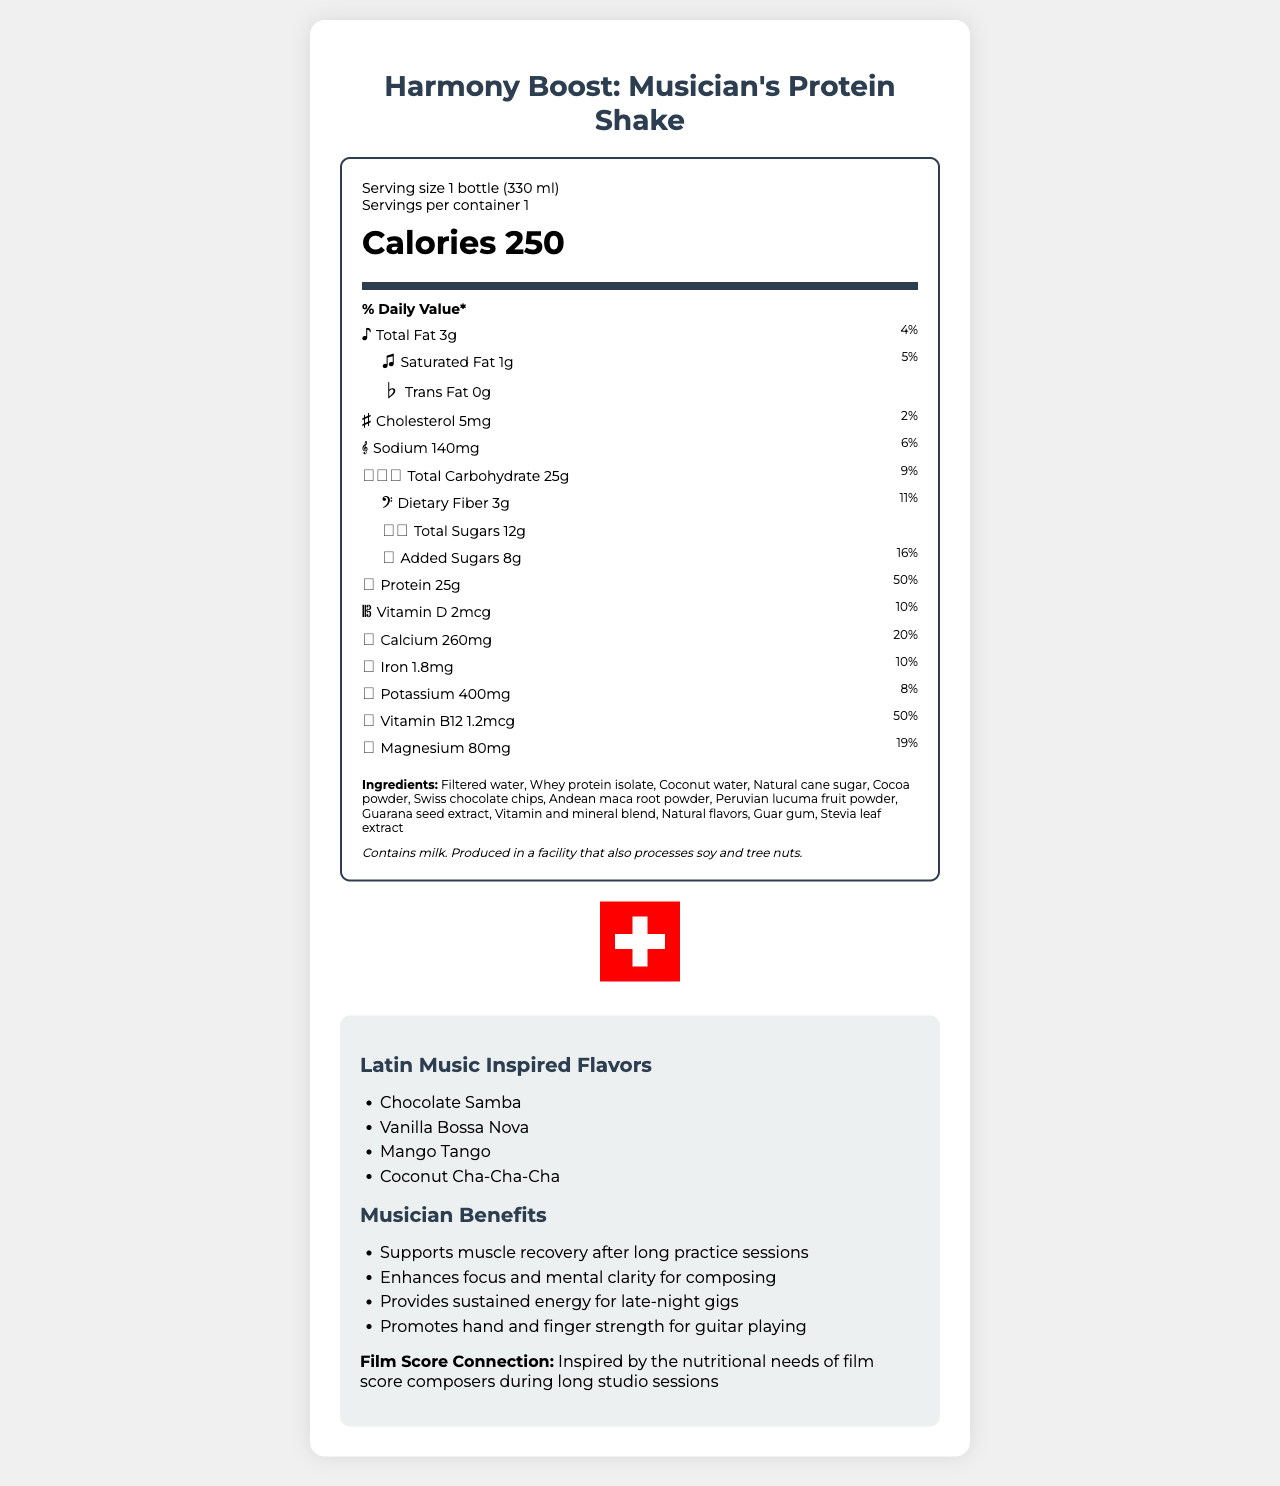what is the serving size? The serving size is mentioned in the serving information in the nutrition label section of the document.
Answer: 1 bottle (330 ml) how much protein does the shake provide? The protein amount is listed under the nutrients section with the note "Protein 25g (𝄚)".
Answer: 25g what is the daily value percentage for calcium? The daily value percentage for calcium is shown in the calcium row in the nutrient section, marked with the icon (𝄔).
Answer: 20% what flavors are available for the protein shake? The flavors are listed under the "Latin Music Inspired Flavors" section of the additional information.
Answer: Chocolate Samba, Vanilla Bossa Nova, Mango Tango, Coconut Cha-Cha-Cha what is the main source of protein in this shake? The main source of protein is listed first in the ingredients list, signifying its prominence in the shake composition.
Answer: Whey protein isolate how many grams of total sugars are in the shake? The total amount of sugars is listed in the nutrient section under "Total Sugars 12g (𝅗𝅥)".
Answer: 12g how much dietary fiber does the shake contain? A. 2g B. 3g C. 4g The document indicates that the shake contains 3g of dietary fiber (𝄢), with an 11% daily value.
Answer: B what percentage of the daily value of vitamin D does this shake provide? A. 5% B. 8% C. 10% D. 12% The shake provides 10% of the daily value for vitamin D, as shown in the nutrient information with the icon (𝄡).
Answer: C does the document specify if the protein shake is suitable for vegans? The document does not provide enough information regarding whether the product is suitable for vegans. It does list "Whey protein isolate" (a milk derivative), indicating it may not be vegan-friendly.
Answer: No is there any allergen information mentioned? The allergen information is included under the ingredients list, stating that the product contains milk and is produced in a facility that also processes soy and tree nuts.
Answer: Yes describe the main idea of the document. The document includes a detailed nutritional value table, a list of ingredients, allergen information, and highlights the product benefits for musicians. It also features unique Latin music-inspired flavors and a Swiss quality seal.
Answer: The document presents the nutrition facts, ingredients, and additional features of "Harmony Boost: Musician's Protein Shake," emphasizing its benefits for musicians and its unique flavors inspired by Latin music. what inspired the nutritional composition of this protein shake? The film score connection section mentions that the nutritional composition is inspired by what film score composers need during lengthy studio sessions.
Answer: Film score composers' nutritional needs during long studio sessions 